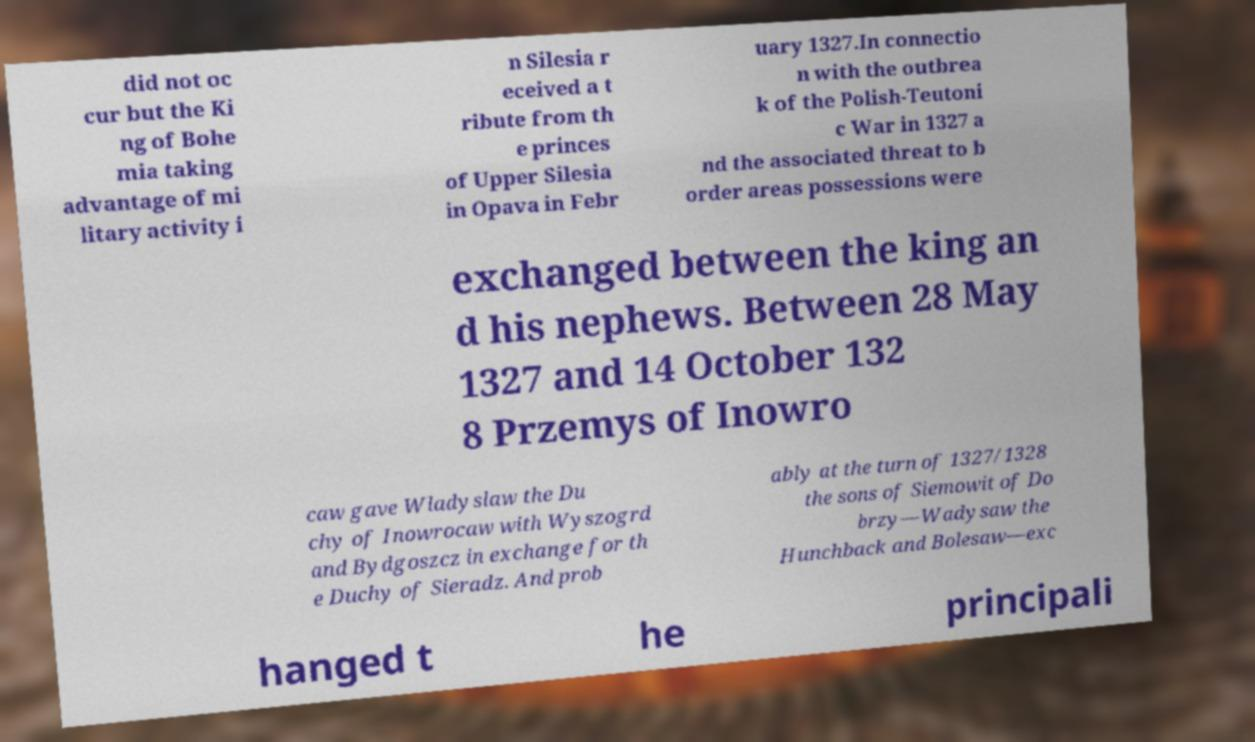For documentation purposes, I need the text within this image transcribed. Could you provide that? did not oc cur but the Ki ng of Bohe mia taking advantage of mi litary activity i n Silesia r eceived a t ribute from th e princes of Upper Silesia in Opava in Febr uary 1327.In connectio n with the outbrea k of the Polish-Teutoni c War in 1327 a nd the associated threat to b order areas possessions were exchanged between the king an d his nephews. Between 28 May 1327 and 14 October 132 8 Przemys of Inowro caw gave Wladyslaw the Du chy of Inowrocaw with Wyszogrd and Bydgoszcz in exchange for th e Duchy of Sieradz. And prob ably at the turn of 1327/1328 the sons of Siemowit of Do brzy—Wadysaw the Hunchback and Bolesaw—exc hanged t he principali 